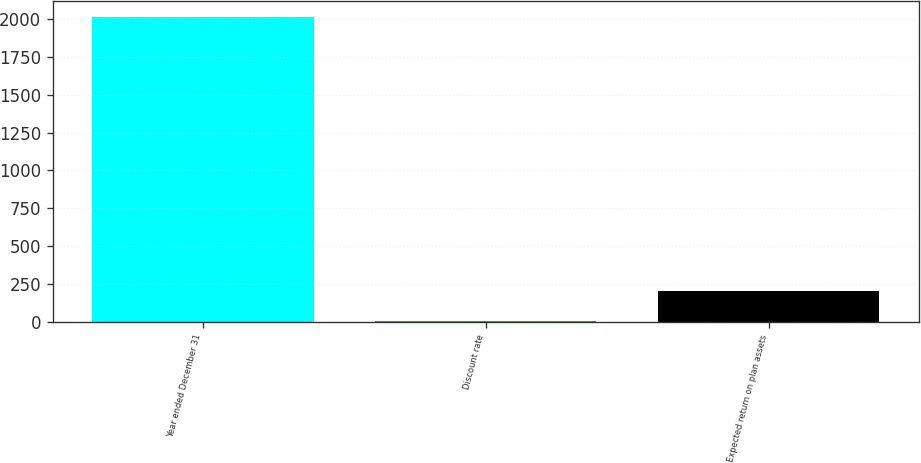Convert chart to OTSL. <chart><loc_0><loc_0><loc_500><loc_500><bar_chart><fcel>Year ended December 31<fcel>Discount rate<fcel>Expected return on plan assets<nl><fcel>2017<fcel>3.75<fcel>205.08<nl></chart> 